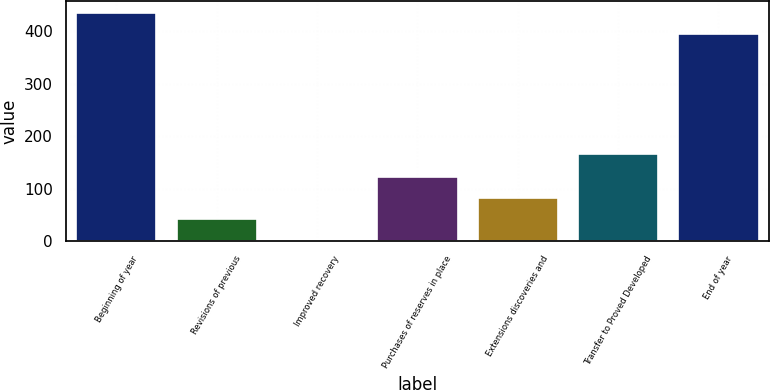<chart> <loc_0><loc_0><loc_500><loc_500><bar_chart><fcel>Beginning of year<fcel>Revisions of previous<fcel>Improved recovery<fcel>Purchases of reserves in place<fcel>Extensions discoveries and<fcel>Transfer to Proved Developed<fcel>End of year<nl><fcel>435.4<fcel>41.4<fcel>1<fcel>122.2<fcel>81.8<fcel>166<fcel>395<nl></chart> 